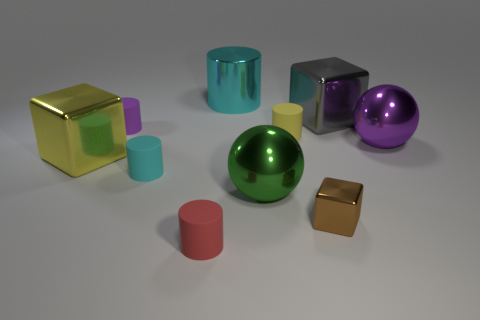Subtract 2 cylinders. How many cylinders are left? 3 Subtract all purple cylinders. How many cylinders are left? 4 Subtract all red cylinders. How many cylinders are left? 4 Subtract all brown cylinders. Subtract all green spheres. How many cylinders are left? 5 Subtract all balls. How many objects are left? 8 Subtract 0 red spheres. How many objects are left? 10 Subtract all big yellow metal blocks. Subtract all large purple cylinders. How many objects are left? 9 Add 9 small red things. How many small red things are left? 10 Add 7 red rubber objects. How many red rubber objects exist? 8 